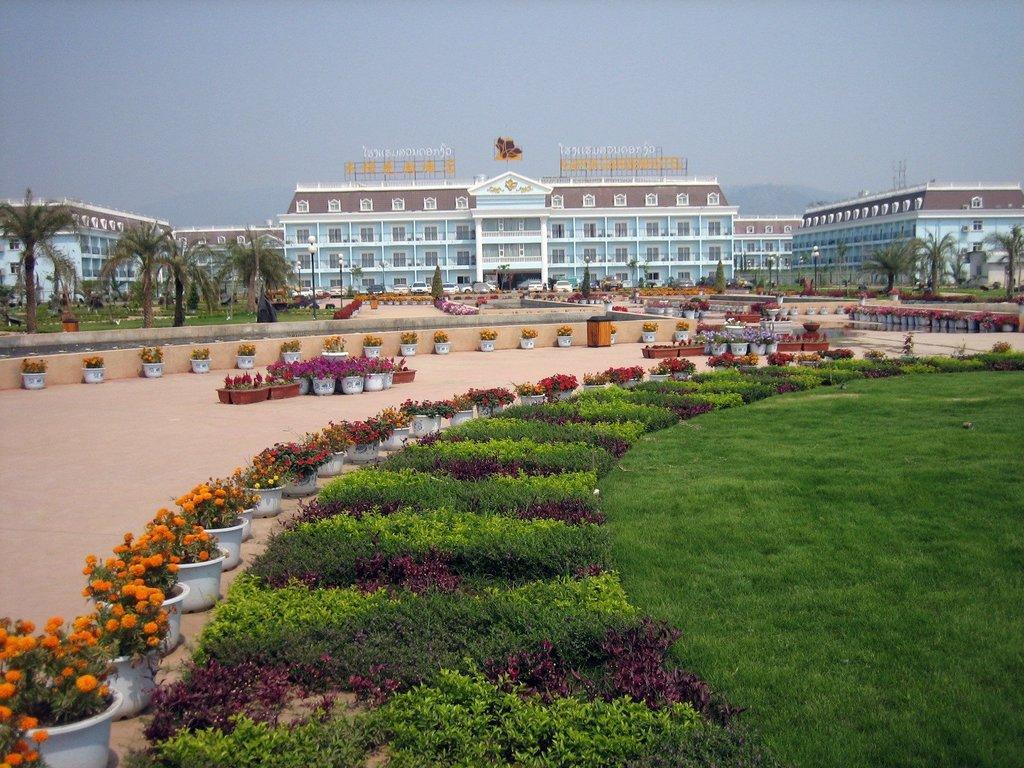Can you describe this image briefly? In the center of the image there is a building. On the right and left of the image we can see buildings and trees. At the bottom of the image we can see house plants and grass. In the background there is a sky. 